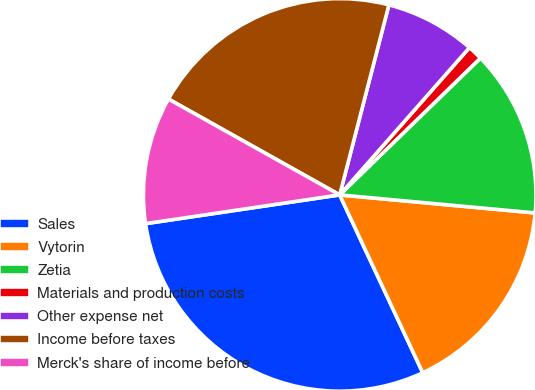Convert chart. <chart><loc_0><loc_0><loc_500><loc_500><pie_chart><fcel>Sales<fcel>Vytorin<fcel>Zetia<fcel>Materials and production costs<fcel>Other expense net<fcel>Income before taxes<fcel>Merck's share of income before<nl><fcel>29.61%<fcel>16.58%<fcel>13.74%<fcel>1.23%<fcel>7.46%<fcel>20.91%<fcel>10.46%<nl></chart> 